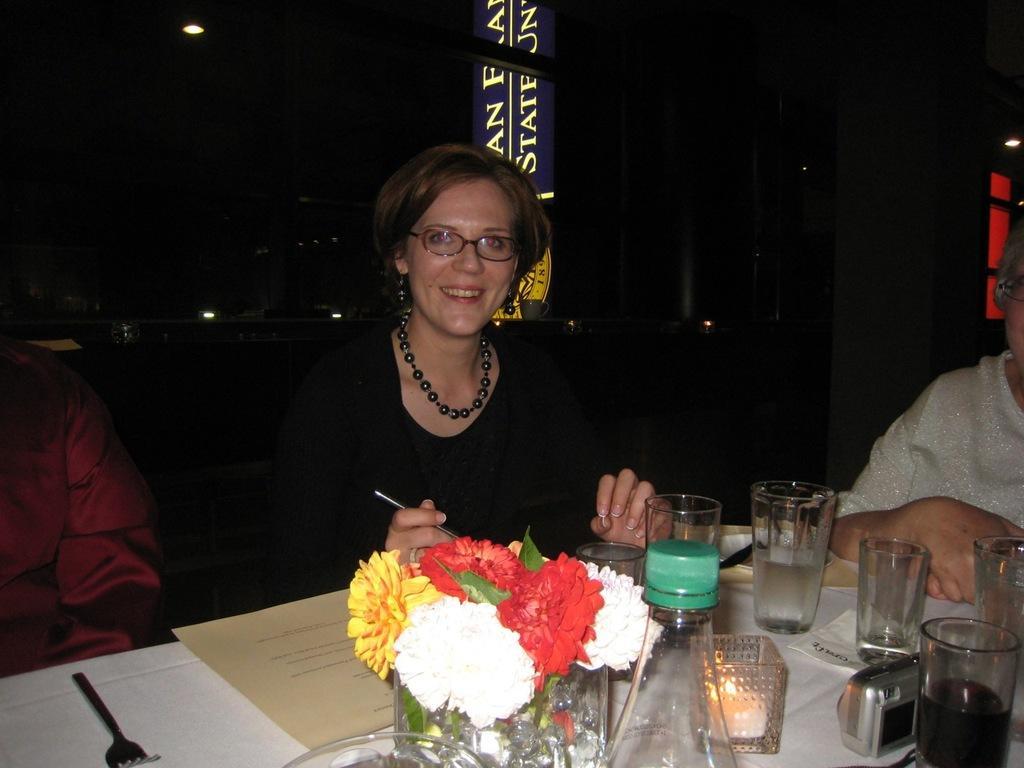Can you describe this image briefly? In this picture we can see two persons, there is a table in the front, we can see some glasses, flowers, a bottle, a paper, a fork, a camera and a tissue paper on this table, in the background there is some text, we can see a dark background. 